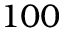<formula> <loc_0><loc_0><loc_500><loc_500>1 0 0</formula> 